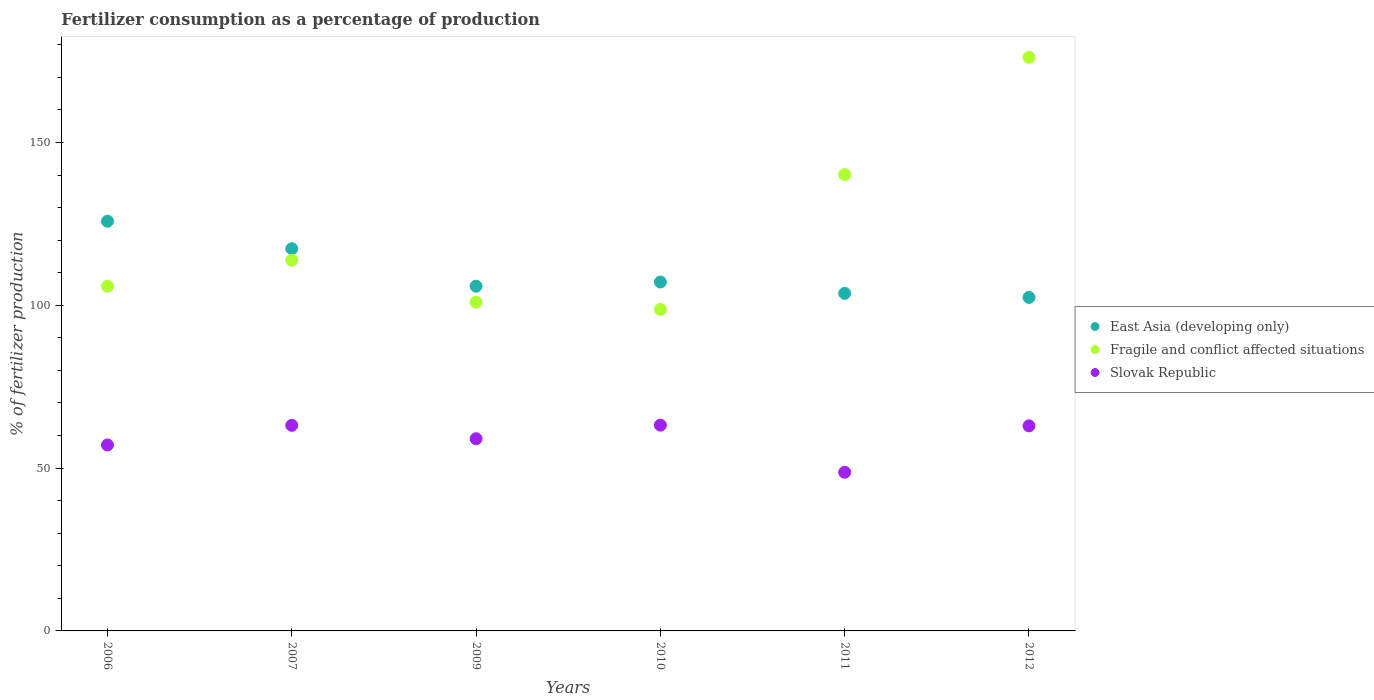How many different coloured dotlines are there?
Your response must be concise. 3. What is the percentage of fertilizers consumed in Fragile and conflict affected situations in 2012?
Your response must be concise. 176.14. Across all years, what is the maximum percentage of fertilizers consumed in Fragile and conflict affected situations?
Give a very brief answer. 176.14. Across all years, what is the minimum percentage of fertilizers consumed in Slovak Republic?
Your response must be concise. 48.72. In which year was the percentage of fertilizers consumed in Fragile and conflict affected situations maximum?
Your answer should be compact. 2012. In which year was the percentage of fertilizers consumed in Slovak Republic minimum?
Make the answer very short. 2011. What is the total percentage of fertilizers consumed in East Asia (developing only) in the graph?
Give a very brief answer. 662.24. What is the difference between the percentage of fertilizers consumed in Slovak Republic in 2006 and that in 2011?
Offer a terse response. 8.38. What is the difference between the percentage of fertilizers consumed in Slovak Republic in 2011 and the percentage of fertilizers consumed in Fragile and conflict affected situations in 2012?
Give a very brief answer. -127.42. What is the average percentage of fertilizers consumed in Fragile and conflict affected situations per year?
Offer a very short reply. 122.6. In the year 2010, what is the difference between the percentage of fertilizers consumed in East Asia (developing only) and percentage of fertilizers consumed in Slovak Republic?
Offer a very short reply. 43.95. In how many years, is the percentage of fertilizers consumed in East Asia (developing only) greater than 160 %?
Your response must be concise. 0. What is the ratio of the percentage of fertilizers consumed in Slovak Republic in 2011 to that in 2012?
Provide a short and direct response. 0.77. Is the percentage of fertilizers consumed in East Asia (developing only) in 2010 less than that in 2011?
Ensure brevity in your answer.  No. Is the difference between the percentage of fertilizers consumed in East Asia (developing only) in 2010 and 2011 greater than the difference between the percentage of fertilizers consumed in Slovak Republic in 2010 and 2011?
Provide a short and direct response. No. What is the difference between the highest and the second highest percentage of fertilizers consumed in East Asia (developing only)?
Offer a terse response. 8.45. What is the difference between the highest and the lowest percentage of fertilizers consumed in Fragile and conflict affected situations?
Ensure brevity in your answer.  77.42. In how many years, is the percentage of fertilizers consumed in Fragile and conflict affected situations greater than the average percentage of fertilizers consumed in Fragile and conflict affected situations taken over all years?
Your response must be concise. 2. Does the percentage of fertilizers consumed in Slovak Republic monotonically increase over the years?
Provide a succinct answer. No. How many years are there in the graph?
Provide a succinct answer. 6. What is the difference between two consecutive major ticks on the Y-axis?
Offer a very short reply. 50. Are the values on the major ticks of Y-axis written in scientific E-notation?
Keep it short and to the point. No. Does the graph contain any zero values?
Give a very brief answer. No. What is the title of the graph?
Make the answer very short. Fertilizer consumption as a percentage of production. What is the label or title of the Y-axis?
Provide a succinct answer. % of fertilizer production. What is the % of fertilizer production of East Asia (developing only) in 2006?
Your answer should be compact. 125.81. What is the % of fertilizer production in Fragile and conflict affected situations in 2006?
Provide a succinct answer. 105.84. What is the % of fertilizer production in Slovak Republic in 2006?
Your answer should be compact. 57.1. What is the % of fertilizer production in East Asia (developing only) in 2007?
Your answer should be compact. 117.36. What is the % of fertilizer production in Fragile and conflict affected situations in 2007?
Provide a succinct answer. 113.84. What is the % of fertilizer production in Slovak Republic in 2007?
Make the answer very short. 63.13. What is the % of fertilizer production of East Asia (developing only) in 2009?
Keep it short and to the point. 105.86. What is the % of fertilizer production of Fragile and conflict affected situations in 2009?
Make the answer very short. 100.93. What is the % of fertilizer production of Slovak Republic in 2009?
Your answer should be very brief. 59.02. What is the % of fertilizer production of East Asia (developing only) in 2010?
Offer a terse response. 107.14. What is the % of fertilizer production of Fragile and conflict affected situations in 2010?
Ensure brevity in your answer.  98.72. What is the % of fertilizer production of Slovak Republic in 2010?
Offer a terse response. 63.19. What is the % of fertilizer production in East Asia (developing only) in 2011?
Keep it short and to the point. 103.65. What is the % of fertilizer production of Fragile and conflict affected situations in 2011?
Provide a short and direct response. 140.13. What is the % of fertilizer production in Slovak Republic in 2011?
Ensure brevity in your answer.  48.72. What is the % of fertilizer production of East Asia (developing only) in 2012?
Offer a terse response. 102.41. What is the % of fertilizer production of Fragile and conflict affected situations in 2012?
Offer a terse response. 176.14. What is the % of fertilizer production of Slovak Republic in 2012?
Ensure brevity in your answer.  62.97. Across all years, what is the maximum % of fertilizer production in East Asia (developing only)?
Offer a very short reply. 125.81. Across all years, what is the maximum % of fertilizer production in Fragile and conflict affected situations?
Your answer should be very brief. 176.14. Across all years, what is the maximum % of fertilizer production of Slovak Republic?
Keep it short and to the point. 63.19. Across all years, what is the minimum % of fertilizer production of East Asia (developing only)?
Offer a very short reply. 102.41. Across all years, what is the minimum % of fertilizer production in Fragile and conflict affected situations?
Your answer should be compact. 98.72. Across all years, what is the minimum % of fertilizer production of Slovak Republic?
Keep it short and to the point. 48.72. What is the total % of fertilizer production of East Asia (developing only) in the graph?
Offer a very short reply. 662.24. What is the total % of fertilizer production of Fragile and conflict affected situations in the graph?
Make the answer very short. 735.59. What is the total % of fertilizer production of Slovak Republic in the graph?
Ensure brevity in your answer.  354.12. What is the difference between the % of fertilizer production in East Asia (developing only) in 2006 and that in 2007?
Offer a terse response. 8.45. What is the difference between the % of fertilizer production of Fragile and conflict affected situations in 2006 and that in 2007?
Provide a short and direct response. -8. What is the difference between the % of fertilizer production of Slovak Republic in 2006 and that in 2007?
Make the answer very short. -6.03. What is the difference between the % of fertilizer production in East Asia (developing only) in 2006 and that in 2009?
Your response must be concise. 19.96. What is the difference between the % of fertilizer production of Fragile and conflict affected situations in 2006 and that in 2009?
Your response must be concise. 4.91. What is the difference between the % of fertilizer production of Slovak Republic in 2006 and that in 2009?
Offer a terse response. -1.92. What is the difference between the % of fertilizer production of East Asia (developing only) in 2006 and that in 2010?
Make the answer very short. 18.67. What is the difference between the % of fertilizer production of Fragile and conflict affected situations in 2006 and that in 2010?
Give a very brief answer. 7.12. What is the difference between the % of fertilizer production in Slovak Republic in 2006 and that in 2010?
Give a very brief answer. -6.09. What is the difference between the % of fertilizer production in East Asia (developing only) in 2006 and that in 2011?
Make the answer very short. 22.16. What is the difference between the % of fertilizer production of Fragile and conflict affected situations in 2006 and that in 2011?
Keep it short and to the point. -34.29. What is the difference between the % of fertilizer production in Slovak Republic in 2006 and that in 2011?
Your response must be concise. 8.38. What is the difference between the % of fertilizer production in East Asia (developing only) in 2006 and that in 2012?
Ensure brevity in your answer.  23.4. What is the difference between the % of fertilizer production in Fragile and conflict affected situations in 2006 and that in 2012?
Your answer should be very brief. -70.3. What is the difference between the % of fertilizer production in Slovak Republic in 2006 and that in 2012?
Offer a very short reply. -5.87. What is the difference between the % of fertilizer production of East Asia (developing only) in 2007 and that in 2009?
Offer a very short reply. 11.51. What is the difference between the % of fertilizer production of Fragile and conflict affected situations in 2007 and that in 2009?
Your answer should be very brief. 12.91. What is the difference between the % of fertilizer production of Slovak Republic in 2007 and that in 2009?
Offer a very short reply. 4.11. What is the difference between the % of fertilizer production of East Asia (developing only) in 2007 and that in 2010?
Make the answer very short. 10.22. What is the difference between the % of fertilizer production of Fragile and conflict affected situations in 2007 and that in 2010?
Your answer should be compact. 15.12. What is the difference between the % of fertilizer production of Slovak Republic in 2007 and that in 2010?
Offer a very short reply. -0.06. What is the difference between the % of fertilizer production of East Asia (developing only) in 2007 and that in 2011?
Provide a short and direct response. 13.71. What is the difference between the % of fertilizer production of Fragile and conflict affected situations in 2007 and that in 2011?
Provide a short and direct response. -26.29. What is the difference between the % of fertilizer production of Slovak Republic in 2007 and that in 2011?
Your answer should be very brief. 14.41. What is the difference between the % of fertilizer production of East Asia (developing only) in 2007 and that in 2012?
Keep it short and to the point. 14.95. What is the difference between the % of fertilizer production in Fragile and conflict affected situations in 2007 and that in 2012?
Make the answer very short. -62.29. What is the difference between the % of fertilizer production of Slovak Republic in 2007 and that in 2012?
Provide a short and direct response. 0.15. What is the difference between the % of fertilizer production of East Asia (developing only) in 2009 and that in 2010?
Offer a very short reply. -1.29. What is the difference between the % of fertilizer production in Fragile and conflict affected situations in 2009 and that in 2010?
Offer a terse response. 2.21. What is the difference between the % of fertilizer production in Slovak Republic in 2009 and that in 2010?
Make the answer very short. -4.17. What is the difference between the % of fertilizer production in East Asia (developing only) in 2009 and that in 2011?
Offer a very short reply. 2.2. What is the difference between the % of fertilizer production of Fragile and conflict affected situations in 2009 and that in 2011?
Keep it short and to the point. -39.2. What is the difference between the % of fertilizer production of Slovak Republic in 2009 and that in 2011?
Offer a terse response. 10.3. What is the difference between the % of fertilizer production in East Asia (developing only) in 2009 and that in 2012?
Make the answer very short. 3.44. What is the difference between the % of fertilizer production of Fragile and conflict affected situations in 2009 and that in 2012?
Give a very brief answer. -75.21. What is the difference between the % of fertilizer production of Slovak Republic in 2009 and that in 2012?
Your answer should be compact. -3.96. What is the difference between the % of fertilizer production in East Asia (developing only) in 2010 and that in 2011?
Your answer should be very brief. 3.49. What is the difference between the % of fertilizer production in Fragile and conflict affected situations in 2010 and that in 2011?
Your response must be concise. -41.41. What is the difference between the % of fertilizer production in Slovak Republic in 2010 and that in 2011?
Offer a very short reply. 14.47. What is the difference between the % of fertilizer production of East Asia (developing only) in 2010 and that in 2012?
Give a very brief answer. 4.73. What is the difference between the % of fertilizer production of Fragile and conflict affected situations in 2010 and that in 2012?
Keep it short and to the point. -77.42. What is the difference between the % of fertilizer production in Slovak Republic in 2010 and that in 2012?
Your answer should be very brief. 0.21. What is the difference between the % of fertilizer production in East Asia (developing only) in 2011 and that in 2012?
Your response must be concise. 1.24. What is the difference between the % of fertilizer production in Fragile and conflict affected situations in 2011 and that in 2012?
Offer a very short reply. -36.01. What is the difference between the % of fertilizer production in Slovak Republic in 2011 and that in 2012?
Keep it short and to the point. -14.26. What is the difference between the % of fertilizer production in East Asia (developing only) in 2006 and the % of fertilizer production in Fragile and conflict affected situations in 2007?
Provide a succinct answer. 11.97. What is the difference between the % of fertilizer production of East Asia (developing only) in 2006 and the % of fertilizer production of Slovak Republic in 2007?
Provide a short and direct response. 62.69. What is the difference between the % of fertilizer production in Fragile and conflict affected situations in 2006 and the % of fertilizer production in Slovak Republic in 2007?
Offer a terse response. 42.71. What is the difference between the % of fertilizer production in East Asia (developing only) in 2006 and the % of fertilizer production in Fragile and conflict affected situations in 2009?
Provide a succinct answer. 24.89. What is the difference between the % of fertilizer production in East Asia (developing only) in 2006 and the % of fertilizer production in Slovak Republic in 2009?
Your answer should be compact. 66.8. What is the difference between the % of fertilizer production of Fragile and conflict affected situations in 2006 and the % of fertilizer production of Slovak Republic in 2009?
Give a very brief answer. 46.82. What is the difference between the % of fertilizer production of East Asia (developing only) in 2006 and the % of fertilizer production of Fragile and conflict affected situations in 2010?
Your response must be concise. 27.09. What is the difference between the % of fertilizer production of East Asia (developing only) in 2006 and the % of fertilizer production of Slovak Republic in 2010?
Make the answer very short. 62.63. What is the difference between the % of fertilizer production in Fragile and conflict affected situations in 2006 and the % of fertilizer production in Slovak Republic in 2010?
Keep it short and to the point. 42.65. What is the difference between the % of fertilizer production in East Asia (developing only) in 2006 and the % of fertilizer production in Fragile and conflict affected situations in 2011?
Your response must be concise. -14.32. What is the difference between the % of fertilizer production of East Asia (developing only) in 2006 and the % of fertilizer production of Slovak Republic in 2011?
Ensure brevity in your answer.  77.1. What is the difference between the % of fertilizer production in Fragile and conflict affected situations in 2006 and the % of fertilizer production in Slovak Republic in 2011?
Ensure brevity in your answer.  57.12. What is the difference between the % of fertilizer production in East Asia (developing only) in 2006 and the % of fertilizer production in Fragile and conflict affected situations in 2012?
Keep it short and to the point. -50.32. What is the difference between the % of fertilizer production of East Asia (developing only) in 2006 and the % of fertilizer production of Slovak Republic in 2012?
Your answer should be compact. 62.84. What is the difference between the % of fertilizer production in Fragile and conflict affected situations in 2006 and the % of fertilizer production in Slovak Republic in 2012?
Your answer should be compact. 42.87. What is the difference between the % of fertilizer production in East Asia (developing only) in 2007 and the % of fertilizer production in Fragile and conflict affected situations in 2009?
Ensure brevity in your answer.  16.43. What is the difference between the % of fertilizer production in East Asia (developing only) in 2007 and the % of fertilizer production in Slovak Republic in 2009?
Offer a terse response. 58.35. What is the difference between the % of fertilizer production in Fragile and conflict affected situations in 2007 and the % of fertilizer production in Slovak Republic in 2009?
Give a very brief answer. 54.83. What is the difference between the % of fertilizer production in East Asia (developing only) in 2007 and the % of fertilizer production in Fragile and conflict affected situations in 2010?
Offer a very short reply. 18.64. What is the difference between the % of fertilizer production in East Asia (developing only) in 2007 and the % of fertilizer production in Slovak Republic in 2010?
Keep it short and to the point. 54.18. What is the difference between the % of fertilizer production of Fragile and conflict affected situations in 2007 and the % of fertilizer production of Slovak Republic in 2010?
Offer a very short reply. 50.65. What is the difference between the % of fertilizer production of East Asia (developing only) in 2007 and the % of fertilizer production of Fragile and conflict affected situations in 2011?
Your answer should be very brief. -22.77. What is the difference between the % of fertilizer production in East Asia (developing only) in 2007 and the % of fertilizer production in Slovak Republic in 2011?
Your answer should be compact. 68.65. What is the difference between the % of fertilizer production in Fragile and conflict affected situations in 2007 and the % of fertilizer production in Slovak Republic in 2011?
Ensure brevity in your answer.  65.13. What is the difference between the % of fertilizer production in East Asia (developing only) in 2007 and the % of fertilizer production in Fragile and conflict affected situations in 2012?
Your answer should be very brief. -58.77. What is the difference between the % of fertilizer production in East Asia (developing only) in 2007 and the % of fertilizer production in Slovak Republic in 2012?
Offer a terse response. 54.39. What is the difference between the % of fertilizer production of Fragile and conflict affected situations in 2007 and the % of fertilizer production of Slovak Republic in 2012?
Provide a short and direct response. 50.87. What is the difference between the % of fertilizer production of East Asia (developing only) in 2009 and the % of fertilizer production of Fragile and conflict affected situations in 2010?
Offer a terse response. 7.13. What is the difference between the % of fertilizer production of East Asia (developing only) in 2009 and the % of fertilizer production of Slovak Republic in 2010?
Keep it short and to the point. 42.67. What is the difference between the % of fertilizer production of Fragile and conflict affected situations in 2009 and the % of fertilizer production of Slovak Republic in 2010?
Keep it short and to the point. 37.74. What is the difference between the % of fertilizer production in East Asia (developing only) in 2009 and the % of fertilizer production in Fragile and conflict affected situations in 2011?
Your answer should be very brief. -34.27. What is the difference between the % of fertilizer production in East Asia (developing only) in 2009 and the % of fertilizer production in Slovak Republic in 2011?
Offer a very short reply. 57.14. What is the difference between the % of fertilizer production in Fragile and conflict affected situations in 2009 and the % of fertilizer production in Slovak Republic in 2011?
Provide a short and direct response. 52.21. What is the difference between the % of fertilizer production of East Asia (developing only) in 2009 and the % of fertilizer production of Fragile and conflict affected situations in 2012?
Ensure brevity in your answer.  -70.28. What is the difference between the % of fertilizer production of East Asia (developing only) in 2009 and the % of fertilizer production of Slovak Republic in 2012?
Your answer should be very brief. 42.88. What is the difference between the % of fertilizer production of Fragile and conflict affected situations in 2009 and the % of fertilizer production of Slovak Republic in 2012?
Offer a terse response. 37.95. What is the difference between the % of fertilizer production of East Asia (developing only) in 2010 and the % of fertilizer production of Fragile and conflict affected situations in 2011?
Make the answer very short. -32.99. What is the difference between the % of fertilizer production of East Asia (developing only) in 2010 and the % of fertilizer production of Slovak Republic in 2011?
Provide a short and direct response. 58.43. What is the difference between the % of fertilizer production of Fragile and conflict affected situations in 2010 and the % of fertilizer production of Slovak Republic in 2011?
Keep it short and to the point. 50.01. What is the difference between the % of fertilizer production in East Asia (developing only) in 2010 and the % of fertilizer production in Fragile and conflict affected situations in 2012?
Keep it short and to the point. -68.99. What is the difference between the % of fertilizer production of East Asia (developing only) in 2010 and the % of fertilizer production of Slovak Republic in 2012?
Your answer should be compact. 44.17. What is the difference between the % of fertilizer production of Fragile and conflict affected situations in 2010 and the % of fertilizer production of Slovak Republic in 2012?
Offer a very short reply. 35.75. What is the difference between the % of fertilizer production of East Asia (developing only) in 2011 and the % of fertilizer production of Fragile and conflict affected situations in 2012?
Your response must be concise. -72.48. What is the difference between the % of fertilizer production in East Asia (developing only) in 2011 and the % of fertilizer production in Slovak Republic in 2012?
Your response must be concise. 40.68. What is the difference between the % of fertilizer production in Fragile and conflict affected situations in 2011 and the % of fertilizer production in Slovak Republic in 2012?
Your response must be concise. 77.16. What is the average % of fertilizer production in East Asia (developing only) per year?
Make the answer very short. 110.37. What is the average % of fertilizer production of Fragile and conflict affected situations per year?
Your answer should be very brief. 122.6. What is the average % of fertilizer production in Slovak Republic per year?
Provide a succinct answer. 59.02. In the year 2006, what is the difference between the % of fertilizer production in East Asia (developing only) and % of fertilizer production in Fragile and conflict affected situations?
Offer a very short reply. 19.98. In the year 2006, what is the difference between the % of fertilizer production of East Asia (developing only) and % of fertilizer production of Slovak Republic?
Your response must be concise. 68.72. In the year 2006, what is the difference between the % of fertilizer production in Fragile and conflict affected situations and % of fertilizer production in Slovak Republic?
Give a very brief answer. 48.74. In the year 2007, what is the difference between the % of fertilizer production in East Asia (developing only) and % of fertilizer production in Fragile and conflict affected situations?
Keep it short and to the point. 3.52. In the year 2007, what is the difference between the % of fertilizer production in East Asia (developing only) and % of fertilizer production in Slovak Republic?
Offer a terse response. 54.24. In the year 2007, what is the difference between the % of fertilizer production in Fragile and conflict affected situations and % of fertilizer production in Slovak Republic?
Your answer should be compact. 50.71. In the year 2009, what is the difference between the % of fertilizer production in East Asia (developing only) and % of fertilizer production in Fragile and conflict affected situations?
Offer a very short reply. 4.93. In the year 2009, what is the difference between the % of fertilizer production of East Asia (developing only) and % of fertilizer production of Slovak Republic?
Keep it short and to the point. 46.84. In the year 2009, what is the difference between the % of fertilizer production of Fragile and conflict affected situations and % of fertilizer production of Slovak Republic?
Your answer should be very brief. 41.91. In the year 2010, what is the difference between the % of fertilizer production of East Asia (developing only) and % of fertilizer production of Fragile and conflict affected situations?
Provide a short and direct response. 8.42. In the year 2010, what is the difference between the % of fertilizer production of East Asia (developing only) and % of fertilizer production of Slovak Republic?
Your response must be concise. 43.95. In the year 2010, what is the difference between the % of fertilizer production of Fragile and conflict affected situations and % of fertilizer production of Slovak Republic?
Your response must be concise. 35.53. In the year 2011, what is the difference between the % of fertilizer production of East Asia (developing only) and % of fertilizer production of Fragile and conflict affected situations?
Make the answer very short. -36.48. In the year 2011, what is the difference between the % of fertilizer production of East Asia (developing only) and % of fertilizer production of Slovak Republic?
Your answer should be compact. 54.94. In the year 2011, what is the difference between the % of fertilizer production of Fragile and conflict affected situations and % of fertilizer production of Slovak Republic?
Make the answer very short. 91.41. In the year 2012, what is the difference between the % of fertilizer production of East Asia (developing only) and % of fertilizer production of Fragile and conflict affected situations?
Keep it short and to the point. -73.72. In the year 2012, what is the difference between the % of fertilizer production in East Asia (developing only) and % of fertilizer production in Slovak Republic?
Your answer should be compact. 39.44. In the year 2012, what is the difference between the % of fertilizer production of Fragile and conflict affected situations and % of fertilizer production of Slovak Republic?
Offer a terse response. 113.16. What is the ratio of the % of fertilizer production of East Asia (developing only) in 2006 to that in 2007?
Provide a succinct answer. 1.07. What is the ratio of the % of fertilizer production of Fragile and conflict affected situations in 2006 to that in 2007?
Offer a terse response. 0.93. What is the ratio of the % of fertilizer production of Slovak Republic in 2006 to that in 2007?
Offer a very short reply. 0.9. What is the ratio of the % of fertilizer production in East Asia (developing only) in 2006 to that in 2009?
Provide a succinct answer. 1.19. What is the ratio of the % of fertilizer production of Fragile and conflict affected situations in 2006 to that in 2009?
Keep it short and to the point. 1.05. What is the ratio of the % of fertilizer production in Slovak Republic in 2006 to that in 2009?
Provide a succinct answer. 0.97. What is the ratio of the % of fertilizer production of East Asia (developing only) in 2006 to that in 2010?
Offer a terse response. 1.17. What is the ratio of the % of fertilizer production in Fragile and conflict affected situations in 2006 to that in 2010?
Your answer should be very brief. 1.07. What is the ratio of the % of fertilizer production of Slovak Republic in 2006 to that in 2010?
Give a very brief answer. 0.9. What is the ratio of the % of fertilizer production of East Asia (developing only) in 2006 to that in 2011?
Offer a terse response. 1.21. What is the ratio of the % of fertilizer production of Fragile and conflict affected situations in 2006 to that in 2011?
Keep it short and to the point. 0.76. What is the ratio of the % of fertilizer production in Slovak Republic in 2006 to that in 2011?
Make the answer very short. 1.17. What is the ratio of the % of fertilizer production in East Asia (developing only) in 2006 to that in 2012?
Your answer should be very brief. 1.23. What is the ratio of the % of fertilizer production in Fragile and conflict affected situations in 2006 to that in 2012?
Give a very brief answer. 0.6. What is the ratio of the % of fertilizer production in Slovak Republic in 2006 to that in 2012?
Your answer should be compact. 0.91. What is the ratio of the % of fertilizer production in East Asia (developing only) in 2007 to that in 2009?
Give a very brief answer. 1.11. What is the ratio of the % of fertilizer production of Fragile and conflict affected situations in 2007 to that in 2009?
Offer a terse response. 1.13. What is the ratio of the % of fertilizer production in Slovak Republic in 2007 to that in 2009?
Provide a short and direct response. 1.07. What is the ratio of the % of fertilizer production in East Asia (developing only) in 2007 to that in 2010?
Give a very brief answer. 1.1. What is the ratio of the % of fertilizer production of Fragile and conflict affected situations in 2007 to that in 2010?
Make the answer very short. 1.15. What is the ratio of the % of fertilizer production in Slovak Republic in 2007 to that in 2010?
Your answer should be very brief. 1. What is the ratio of the % of fertilizer production of East Asia (developing only) in 2007 to that in 2011?
Your response must be concise. 1.13. What is the ratio of the % of fertilizer production of Fragile and conflict affected situations in 2007 to that in 2011?
Keep it short and to the point. 0.81. What is the ratio of the % of fertilizer production in Slovak Republic in 2007 to that in 2011?
Your answer should be compact. 1.3. What is the ratio of the % of fertilizer production in East Asia (developing only) in 2007 to that in 2012?
Make the answer very short. 1.15. What is the ratio of the % of fertilizer production in Fragile and conflict affected situations in 2007 to that in 2012?
Provide a succinct answer. 0.65. What is the ratio of the % of fertilizer production in East Asia (developing only) in 2009 to that in 2010?
Offer a very short reply. 0.99. What is the ratio of the % of fertilizer production of Fragile and conflict affected situations in 2009 to that in 2010?
Your response must be concise. 1.02. What is the ratio of the % of fertilizer production of Slovak Republic in 2009 to that in 2010?
Make the answer very short. 0.93. What is the ratio of the % of fertilizer production of East Asia (developing only) in 2009 to that in 2011?
Provide a short and direct response. 1.02. What is the ratio of the % of fertilizer production in Fragile and conflict affected situations in 2009 to that in 2011?
Your response must be concise. 0.72. What is the ratio of the % of fertilizer production of Slovak Republic in 2009 to that in 2011?
Offer a terse response. 1.21. What is the ratio of the % of fertilizer production of East Asia (developing only) in 2009 to that in 2012?
Provide a short and direct response. 1.03. What is the ratio of the % of fertilizer production of Fragile and conflict affected situations in 2009 to that in 2012?
Your answer should be compact. 0.57. What is the ratio of the % of fertilizer production of Slovak Republic in 2009 to that in 2012?
Offer a terse response. 0.94. What is the ratio of the % of fertilizer production of East Asia (developing only) in 2010 to that in 2011?
Offer a terse response. 1.03. What is the ratio of the % of fertilizer production in Fragile and conflict affected situations in 2010 to that in 2011?
Your answer should be compact. 0.7. What is the ratio of the % of fertilizer production of Slovak Republic in 2010 to that in 2011?
Give a very brief answer. 1.3. What is the ratio of the % of fertilizer production in East Asia (developing only) in 2010 to that in 2012?
Ensure brevity in your answer.  1.05. What is the ratio of the % of fertilizer production in Fragile and conflict affected situations in 2010 to that in 2012?
Provide a succinct answer. 0.56. What is the ratio of the % of fertilizer production in East Asia (developing only) in 2011 to that in 2012?
Provide a succinct answer. 1.01. What is the ratio of the % of fertilizer production of Fragile and conflict affected situations in 2011 to that in 2012?
Keep it short and to the point. 0.8. What is the ratio of the % of fertilizer production of Slovak Republic in 2011 to that in 2012?
Give a very brief answer. 0.77. What is the difference between the highest and the second highest % of fertilizer production in East Asia (developing only)?
Give a very brief answer. 8.45. What is the difference between the highest and the second highest % of fertilizer production of Fragile and conflict affected situations?
Provide a short and direct response. 36.01. What is the difference between the highest and the second highest % of fertilizer production in Slovak Republic?
Your response must be concise. 0.06. What is the difference between the highest and the lowest % of fertilizer production of East Asia (developing only)?
Offer a terse response. 23.4. What is the difference between the highest and the lowest % of fertilizer production in Fragile and conflict affected situations?
Provide a succinct answer. 77.42. What is the difference between the highest and the lowest % of fertilizer production in Slovak Republic?
Provide a short and direct response. 14.47. 